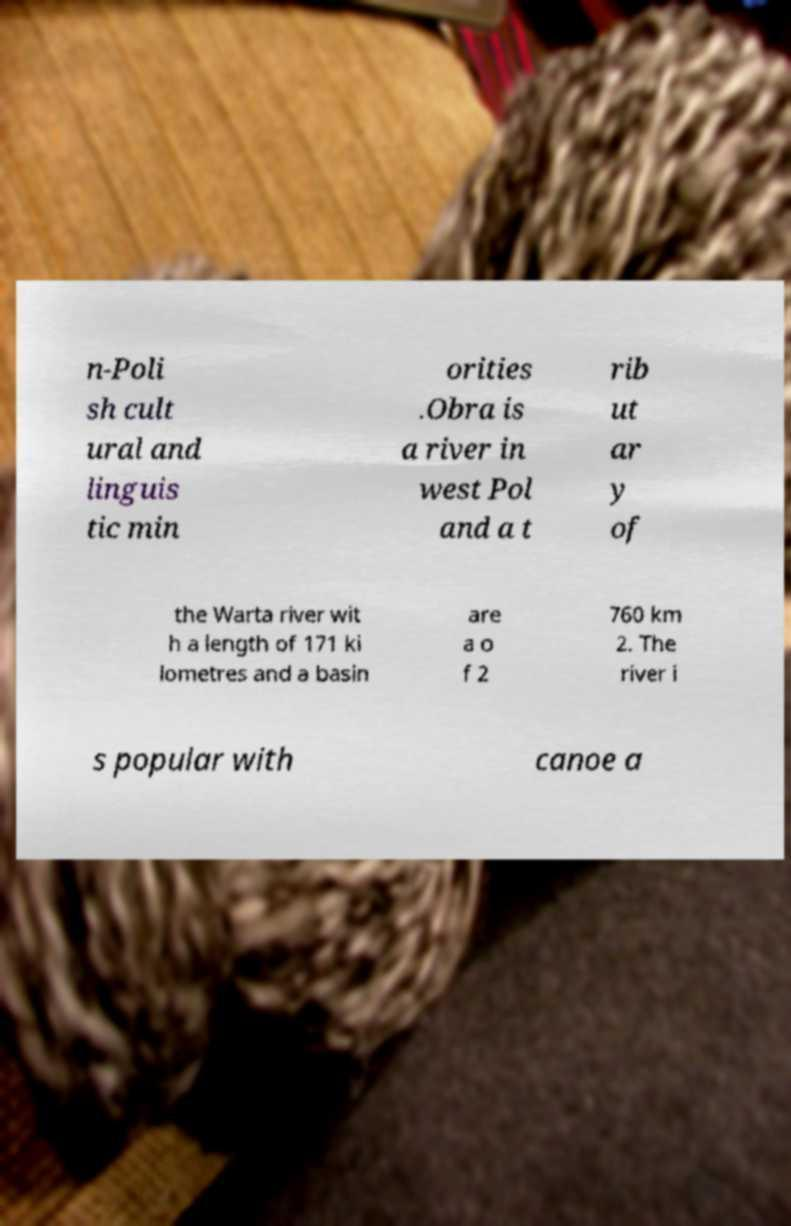Please identify and transcribe the text found in this image. n-Poli sh cult ural and linguis tic min orities .Obra is a river in west Pol and a t rib ut ar y of the Warta river wit h a length of 171 ki lometres and a basin are a o f 2 760 km 2. The river i s popular with canoe a 